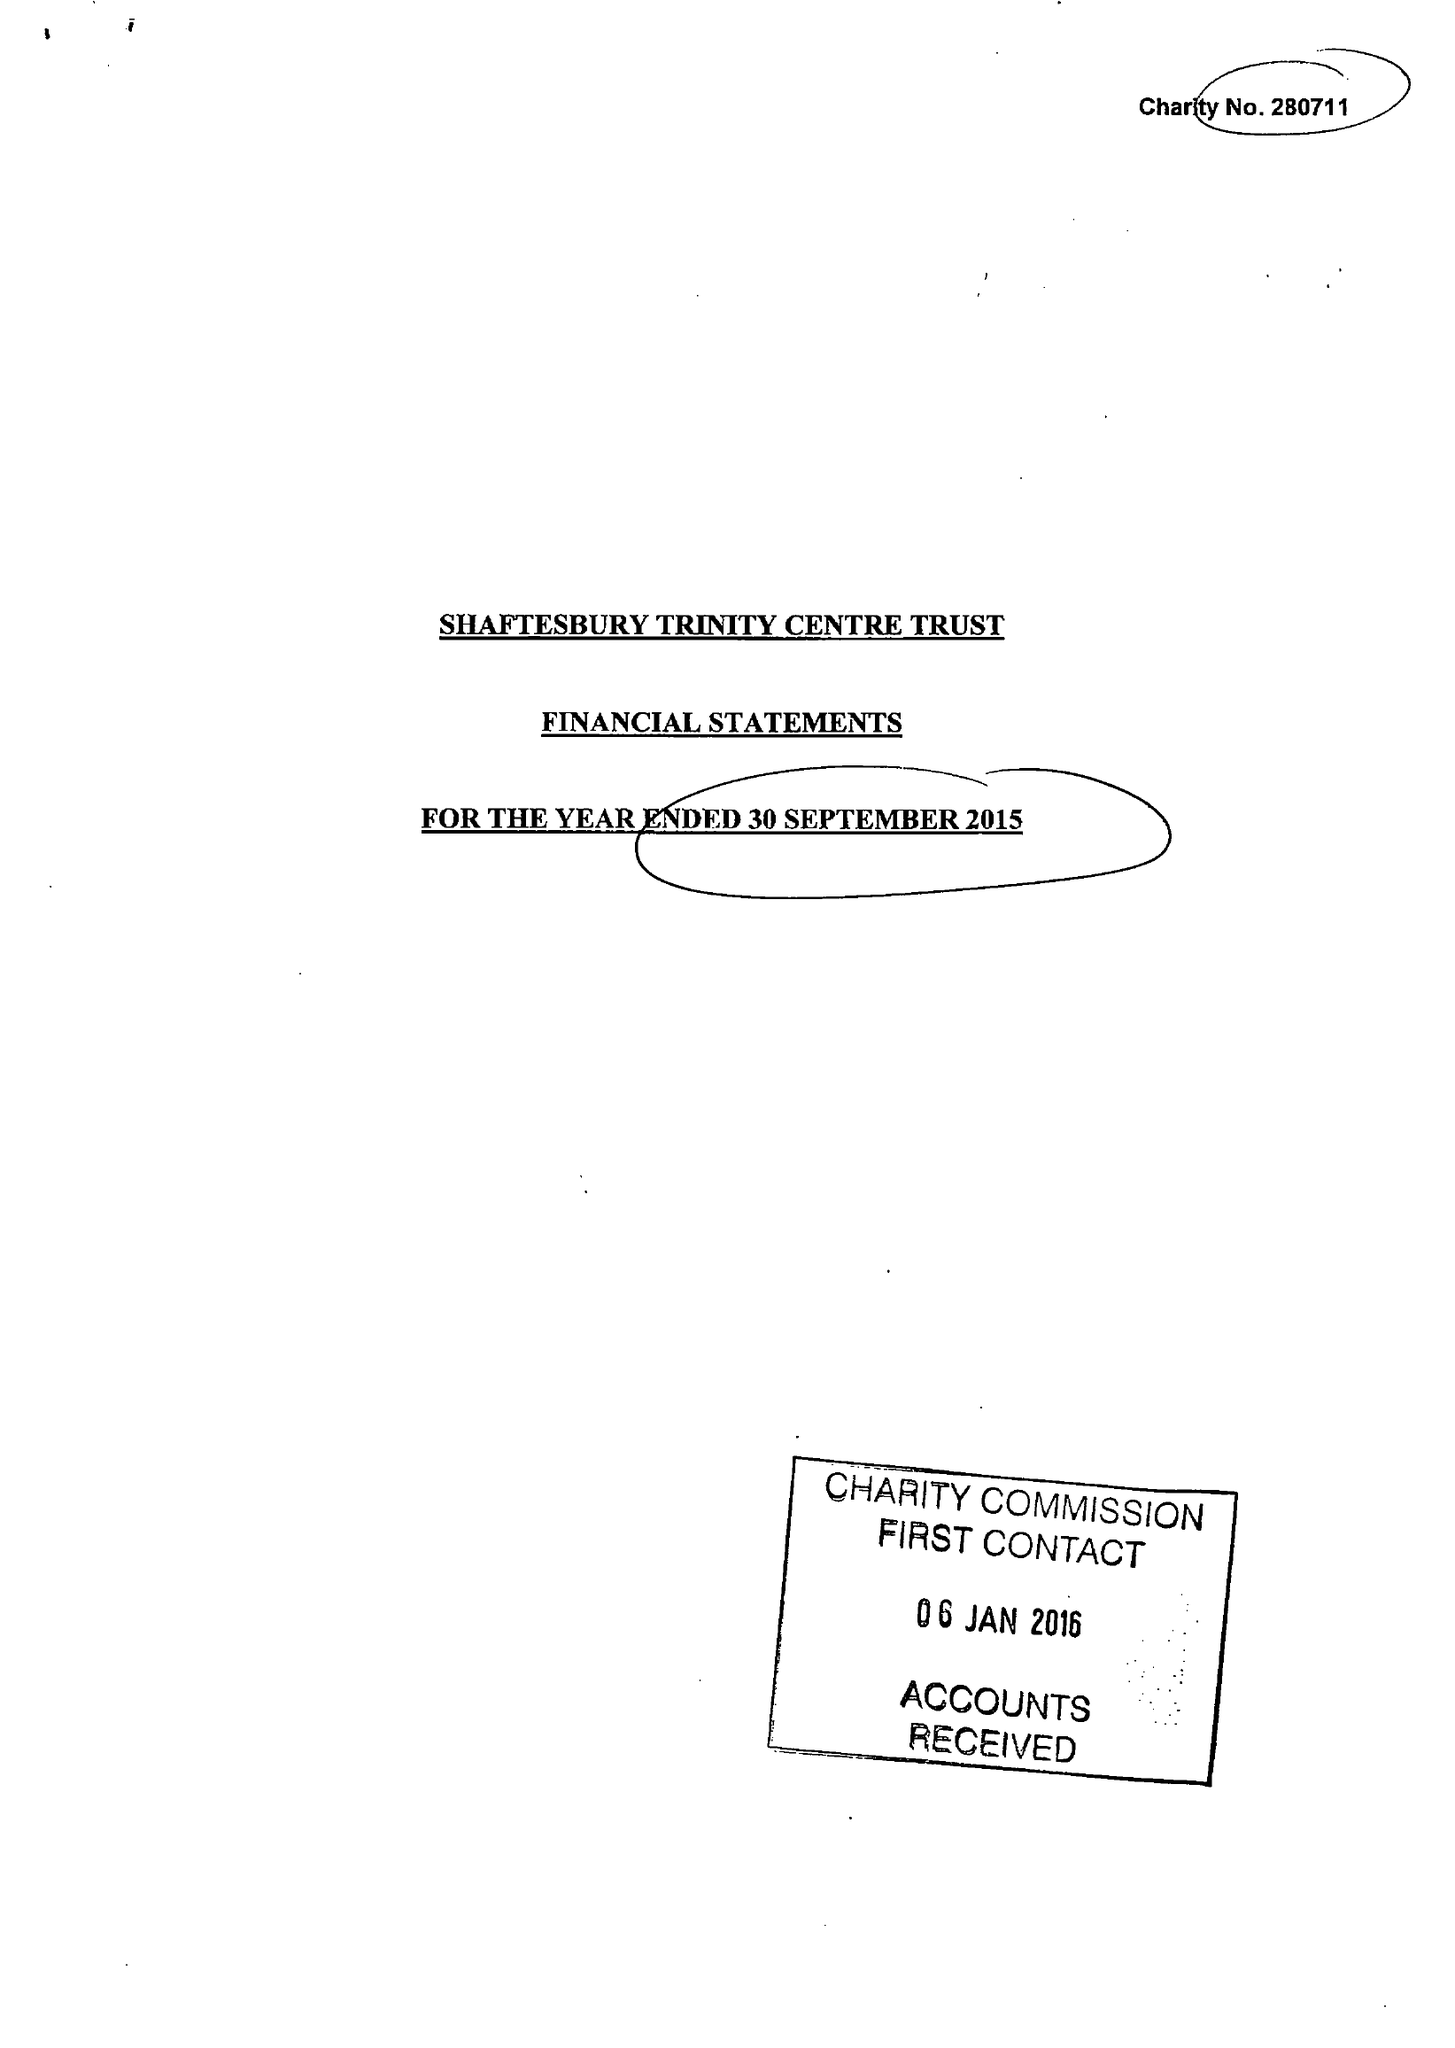What is the value for the report_date?
Answer the question using a single word or phrase. 2015-09-30 